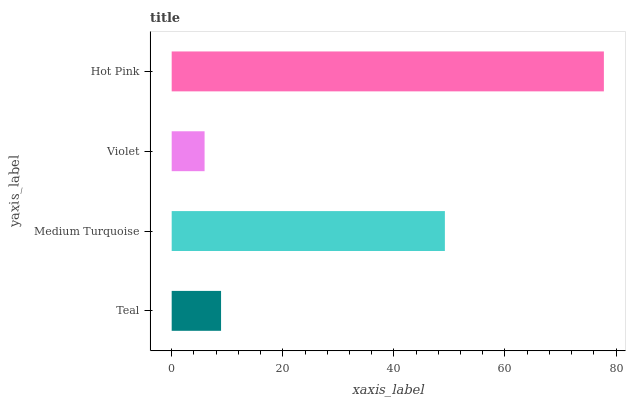Is Violet the minimum?
Answer yes or no. Yes. Is Hot Pink the maximum?
Answer yes or no. Yes. Is Medium Turquoise the minimum?
Answer yes or no. No. Is Medium Turquoise the maximum?
Answer yes or no. No. Is Medium Turquoise greater than Teal?
Answer yes or no. Yes. Is Teal less than Medium Turquoise?
Answer yes or no. Yes. Is Teal greater than Medium Turquoise?
Answer yes or no. No. Is Medium Turquoise less than Teal?
Answer yes or no. No. Is Medium Turquoise the high median?
Answer yes or no. Yes. Is Teal the low median?
Answer yes or no. Yes. Is Teal the high median?
Answer yes or no. No. Is Violet the low median?
Answer yes or no. No. 